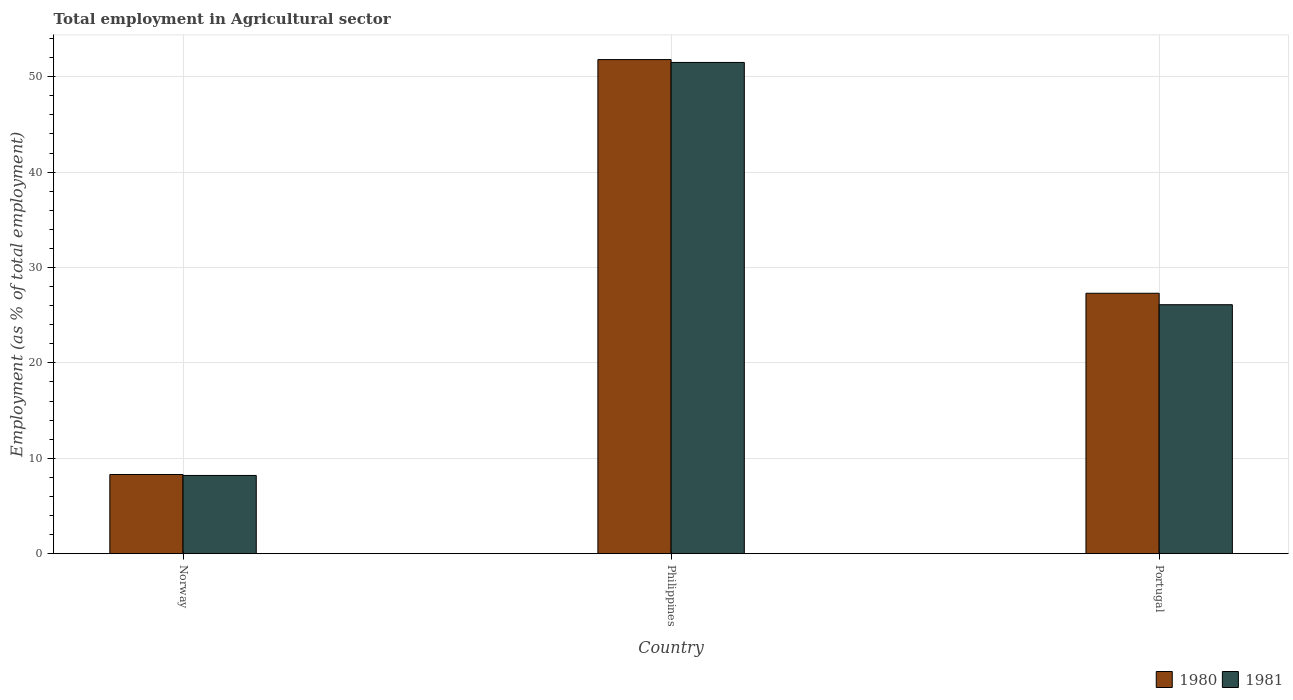How many groups of bars are there?
Your response must be concise. 3. Are the number of bars on each tick of the X-axis equal?
Give a very brief answer. Yes. What is the label of the 3rd group of bars from the left?
Provide a short and direct response. Portugal. In how many cases, is the number of bars for a given country not equal to the number of legend labels?
Offer a terse response. 0. What is the employment in agricultural sector in 1980 in Philippines?
Provide a short and direct response. 51.8. Across all countries, what is the maximum employment in agricultural sector in 1980?
Offer a terse response. 51.8. Across all countries, what is the minimum employment in agricultural sector in 1981?
Your response must be concise. 8.2. In which country was the employment in agricultural sector in 1981 maximum?
Ensure brevity in your answer.  Philippines. In which country was the employment in agricultural sector in 1981 minimum?
Provide a short and direct response. Norway. What is the total employment in agricultural sector in 1980 in the graph?
Provide a short and direct response. 87.4. What is the difference between the employment in agricultural sector in 1981 in Philippines and that in Portugal?
Offer a terse response. 25.4. What is the difference between the employment in agricultural sector in 1980 in Norway and the employment in agricultural sector in 1981 in Philippines?
Your answer should be compact. -43.2. What is the average employment in agricultural sector in 1980 per country?
Your answer should be very brief. 29.13. What is the difference between the employment in agricultural sector of/in 1981 and employment in agricultural sector of/in 1980 in Philippines?
Ensure brevity in your answer.  -0.3. In how many countries, is the employment in agricultural sector in 1980 greater than 36 %?
Your answer should be very brief. 1. What is the ratio of the employment in agricultural sector in 1981 in Norway to that in Portugal?
Your answer should be very brief. 0.31. What is the difference between the highest and the second highest employment in agricultural sector in 1980?
Provide a short and direct response. 19. What is the difference between the highest and the lowest employment in agricultural sector in 1981?
Provide a short and direct response. 43.3. Is the sum of the employment in agricultural sector in 1981 in Norway and Portugal greater than the maximum employment in agricultural sector in 1980 across all countries?
Offer a terse response. No. What does the 2nd bar from the right in Philippines represents?
Offer a very short reply. 1980. How many bars are there?
Provide a short and direct response. 6. How many countries are there in the graph?
Offer a terse response. 3. Does the graph contain any zero values?
Keep it short and to the point. No. How many legend labels are there?
Make the answer very short. 2. How are the legend labels stacked?
Your response must be concise. Horizontal. What is the title of the graph?
Offer a very short reply. Total employment in Agricultural sector. What is the label or title of the Y-axis?
Ensure brevity in your answer.  Employment (as % of total employment). What is the Employment (as % of total employment) of 1980 in Norway?
Provide a succinct answer. 8.3. What is the Employment (as % of total employment) in 1981 in Norway?
Your answer should be compact. 8.2. What is the Employment (as % of total employment) in 1980 in Philippines?
Offer a terse response. 51.8. What is the Employment (as % of total employment) of 1981 in Philippines?
Give a very brief answer. 51.5. What is the Employment (as % of total employment) in 1980 in Portugal?
Your answer should be compact. 27.3. What is the Employment (as % of total employment) of 1981 in Portugal?
Your answer should be very brief. 26.1. Across all countries, what is the maximum Employment (as % of total employment) in 1980?
Your answer should be very brief. 51.8. Across all countries, what is the maximum Employment (as % of total employment) of 1981?
Your response must be concise. 51.5. Across all countries, what is the minimum Employment (as % of total employment) of 1980?
Give a very brief answer. 8.3. Across all countries, what is the minimum Employment (as % of total employment) of 1981?
Offer a terse response. 8.2. What is the total Employment (as % of total employment) of 1980 in the graph?
Ensure brevity in your answer.  87.4. What is the total Employment (as % of total employment) of 1981 in the graph?
Give a very brief answer. 85.8. What is the difference between the Employment (as % of total employment) of 1980 in Norway and that in Philippines?
Offer a terse response. -43.5. What is the difference between the Employment (as % of total employment) in 1981 in Norway and that in Philippines?
Your response must be concise. -43.3. What is the difference between the Employment (as % of total employment) in 1980 in Norway and that in Portugal?
Provide a succinct answer. -19. What is the difference between the Employment (as % of total employment) in 1981 in Norway and that in Portugal?
Your answer should be very brief. -17.9. What is the difference between the Employment (as % of total employment) in 1981 in Philippines and that in Portugal?
Your answer should be very brief. 25.4. What is the difference between the Employment (as % of total employment) of 1980 in Norway and the Employment (as % of total employment) of 1981 in Philippines?
Ensure brevity in your answer.  -43.2. What is the difference between the Employment (as % of total employment) of 1980 in Norway and the Employment (as % of total employment) of 1981 in Portugal?
Make the answer very short. -17.8. What is the difference between the Employment (as % of total employment) of 1980 in Philippines and the Employment (as % of total employment) of 1981 in Portugal?
Your answer should be very brief. 25.7. What is the average Employment (as % of total employment) in 1980 per country?
Ensure brevity in your answer.  29.13. What is the average Employment (as % of total employment) in 1981 per country?
Ensure brevity in your answer.  28.6. What is the difference between the Employment (as % of total employment) of 1980 and Employment (as % of total employment) of 1981 in Norway?
Make the answer very short. 0.1. What is the difference between the Employment (as % of total employment) in 1980 and Employment (as % of total employment) in 1981 in Philippines?
Offer a very short reply. 0.3. What is the difference between the Employment (as % of total employment) in 1980 and Employment (as % of total employment) in 1981 in Portugal?
Your answer should be compact. 1.2. What is the ratio of the Employment (as % of total employment) of 1980 in Norway to that in Philippines?
Ensure brevity in your answer.  0.16. What is the ratio of the Employment (as % of total employment) of 1981 in Norway to that in Philippines?
Give a very brief answer. 0.16. What is the ratio of the Employment (as % of total employment) of 1980 in Norway to that in Portugal?
Provide a succinct answer. 0.3. What is the ratio of the Employment (as % of total employment) in 1981 in Norway to that in Portugal?
Provide a succinct answer. 0.31. What is the ratio of the Employment (as % of total employment) in 1980 in Philippines to that in Portugal?
Your response must be concise. 1.9. What is the ratio of the Employment (as % of total employment) in 1981 in Philippines to that in Portugal?
Keep it short and to the point. 1.97. What is the difference between the highest and the second highest Employment (as % of total employment) in 1980?
Keep it short and to the point. 24.5. What is the difference between the highest and the second highest Employment (as % of total employment) in 1981?
Offer a terse response. 25.4. What is the difference between the highest and the lowest Employment (as % of total employment) of 1980?
Your answer should be compact. 43.5. What is the difference between the highest and the lowest Employment (as % of total employment) in 1981?
Offer a terse response. 43.3. 